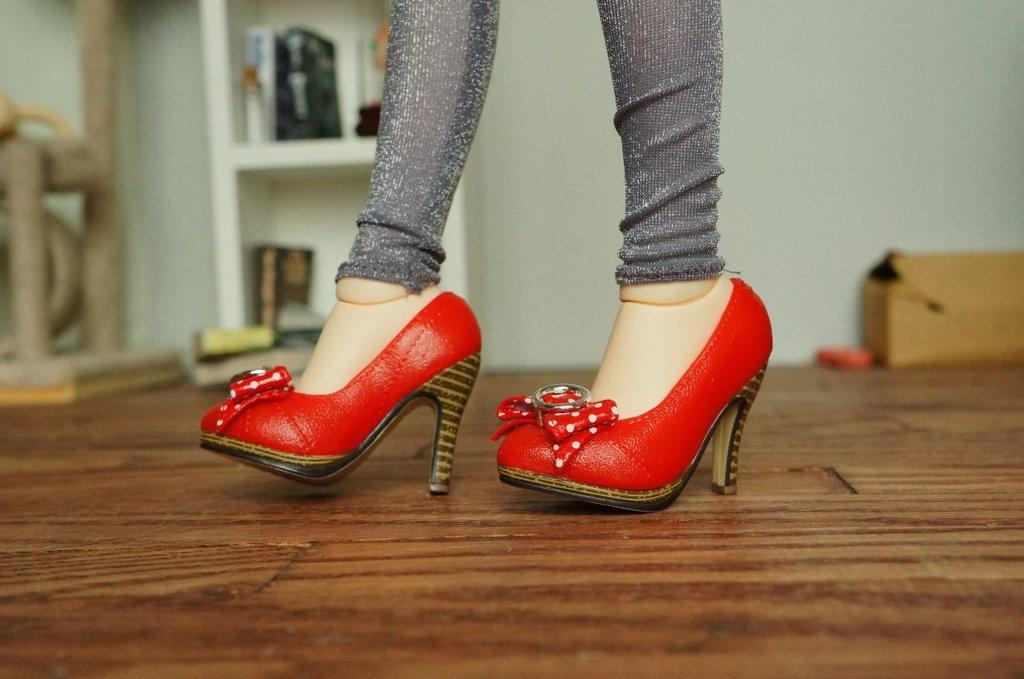What body parts are visible in the image? There are women's legs in the image. What can be observed about the shoes on the women's legs? The shoes on the women's legs are red in color. What type of snake can be seen wrapped around the women's legs in the image? There is no snake present in the image; it only features women's legs and red shoes. 